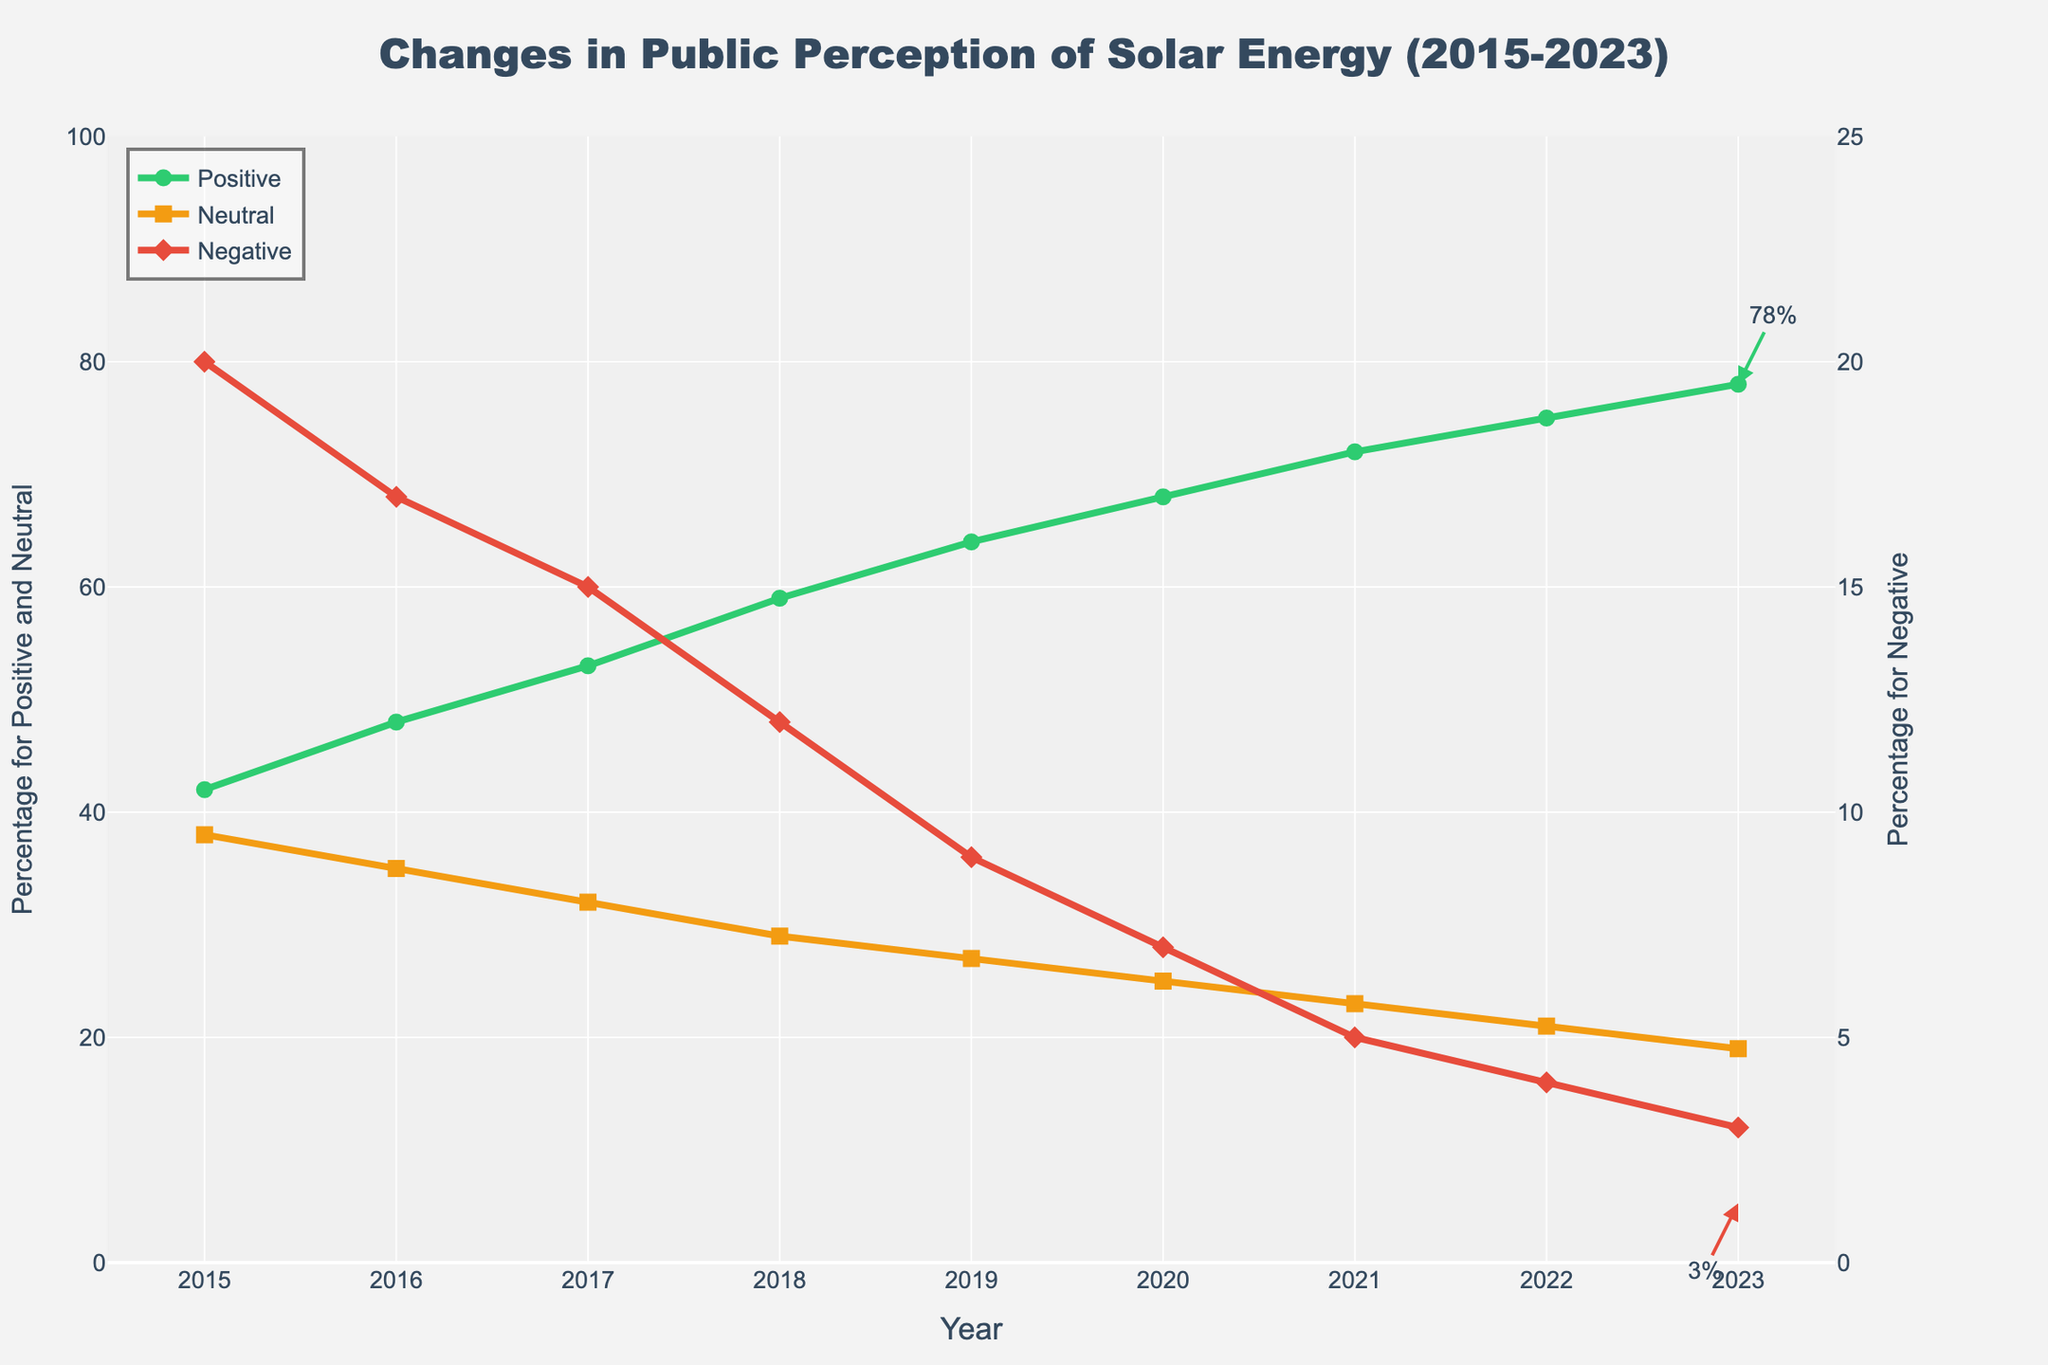What is the trend for the percentage of positive sentiment from 2015 to 2023? The percentage of positive sentiment increases each year from 42% in 2015 to 78% in 2023.
Answer: Increasing How does the percentage of neutral sentiment change from 2015 to 2023? The percentage of neutral sentiment decreases steadily each year, from 38% in 2015 to 19% in 2023.
Answer: Decreasing In which year does the percentage of negative sentiment drop below 10%? The percentage of negative sentiment drops below 10% in the year 2019, when it is 9%.
Answer: 2019 What is the total increase in positive sentiment from 2015 to 2023? To find the total increase, subtract the percentage in 2015 from the percentage in 2023: 78% - 42% = 36%.
Answer: 36% Compare the percentages of positive and negative sentiments in 2023. Which is higher and by how much? The positive sentiment in 2023 is 78%, and the negative sentiment is 3%. The positive sentiment is higher by 78% - 3% = 75%.
Answer: Positive, 75% In which year do positive and neutral sentiments intersect, or come closest to each other? Examine the plotted lines to see where positive and neutral sentiments are closest. In 2018, the percentages are 59% for positive and 29% for neutral.
Answer: 2018 What is the overall trend for the negative sentiment from 2015 to 2023? The percentage of negative sentiment decreases consistently from 20% in 2015 to 3% in 2023.
Answer: Decreasing How much did the percentage of neutral sentiment decrease from 2017 to 2020? Subtract the 2020 percentage from the 2017 percentage: 32% - 25% = 7%.
Answer: 7% What is the sum of the positive and neutral sentiments in 2023? Add the percentages of positive and neutral sentiments for 2023: 78% + 19% = 97%.
Answer: 97% Which sentiment category shows the steepest decline, and during which interval? The negative sentiment shows the steepest decline, particularly from 2019 to 2021, where it drops from 9% to 5%.
Answer: Negative, 2019-2021 